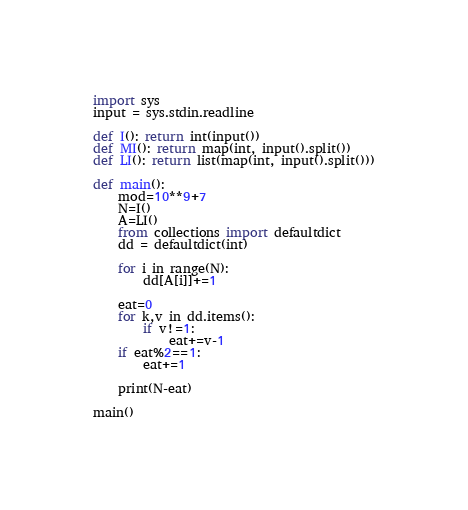Convert code to text. <code><loc_0><loc_0><loc_500><loc_500><_Python_>import sys
input = sys.stdin.readline

def I(): return int(input())
def MI(): return map(int, input().split())
def LI(): return list(map(int, input().split()))

def main():
    mod=10**9+7
    N=I()
    A=LI()
    from collections import defaultdict
    dd = defaultdict(int)
    
    for i in range(N):
        dd[A[i]]+=1
        
    eat=0
    for k,v in dd.items():
        if v!=1:
            eat+=v-1
    if eat%2==1:
        eat+=1        
    
    print(N-eat)

main()
</code> 